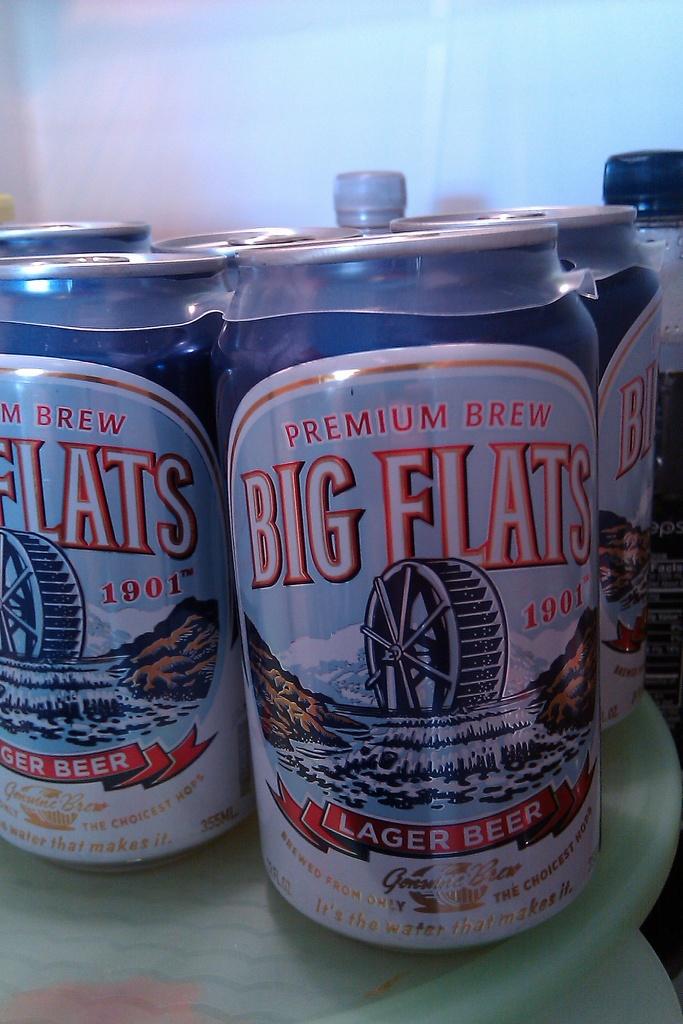What is the beer name?
Your answer should be compact. Big flats. 